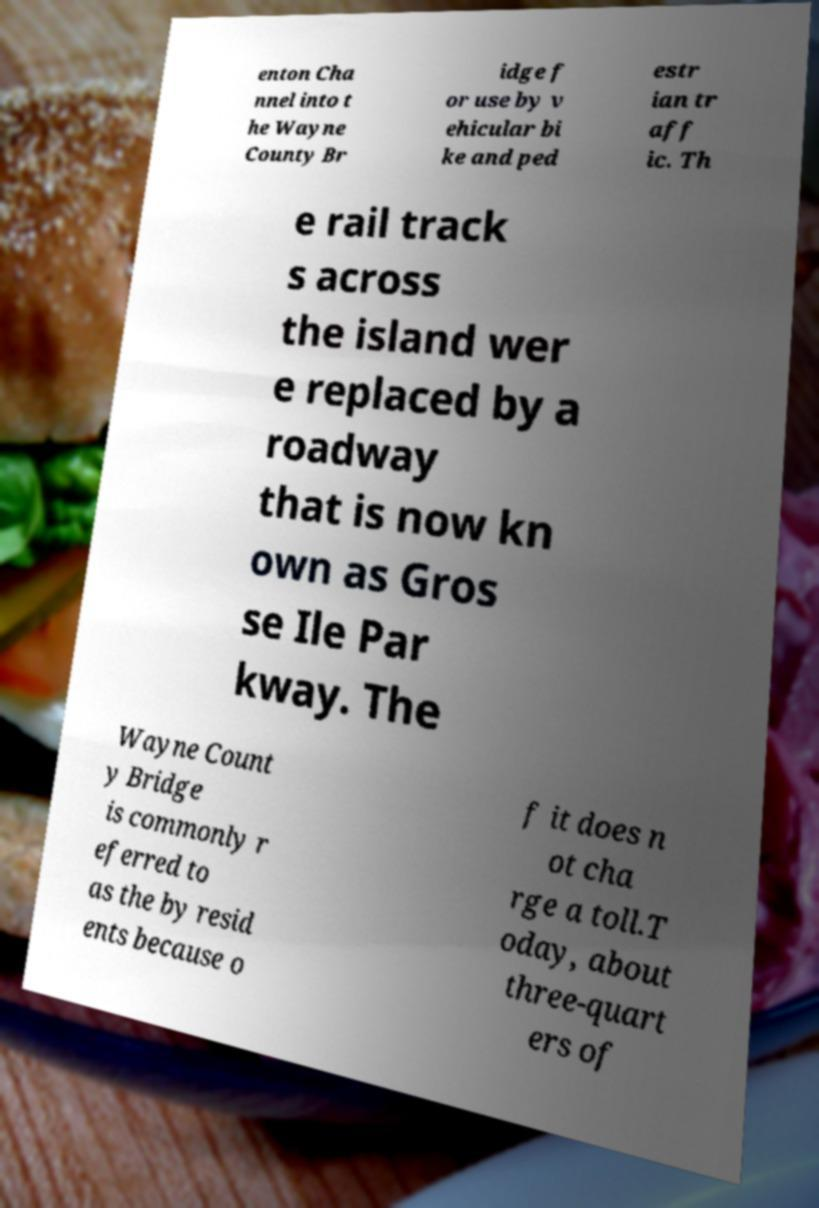For documentation purposes, I need the text within this image transcribed. Could you provide that? enton Cha nnel into t he Wayne County Br idge f or use by v ehicular bi ke and ped estr ian tr aff ic. Th e rail track s across the island wer e replaced by a roadway that is now kn own as Gros se Ile Par kway. The Wayne Count y Bridge is commonly r eferred to as the by resid ents because o f it does n ot cha rge a toll.T oday, about three-quart ers of 